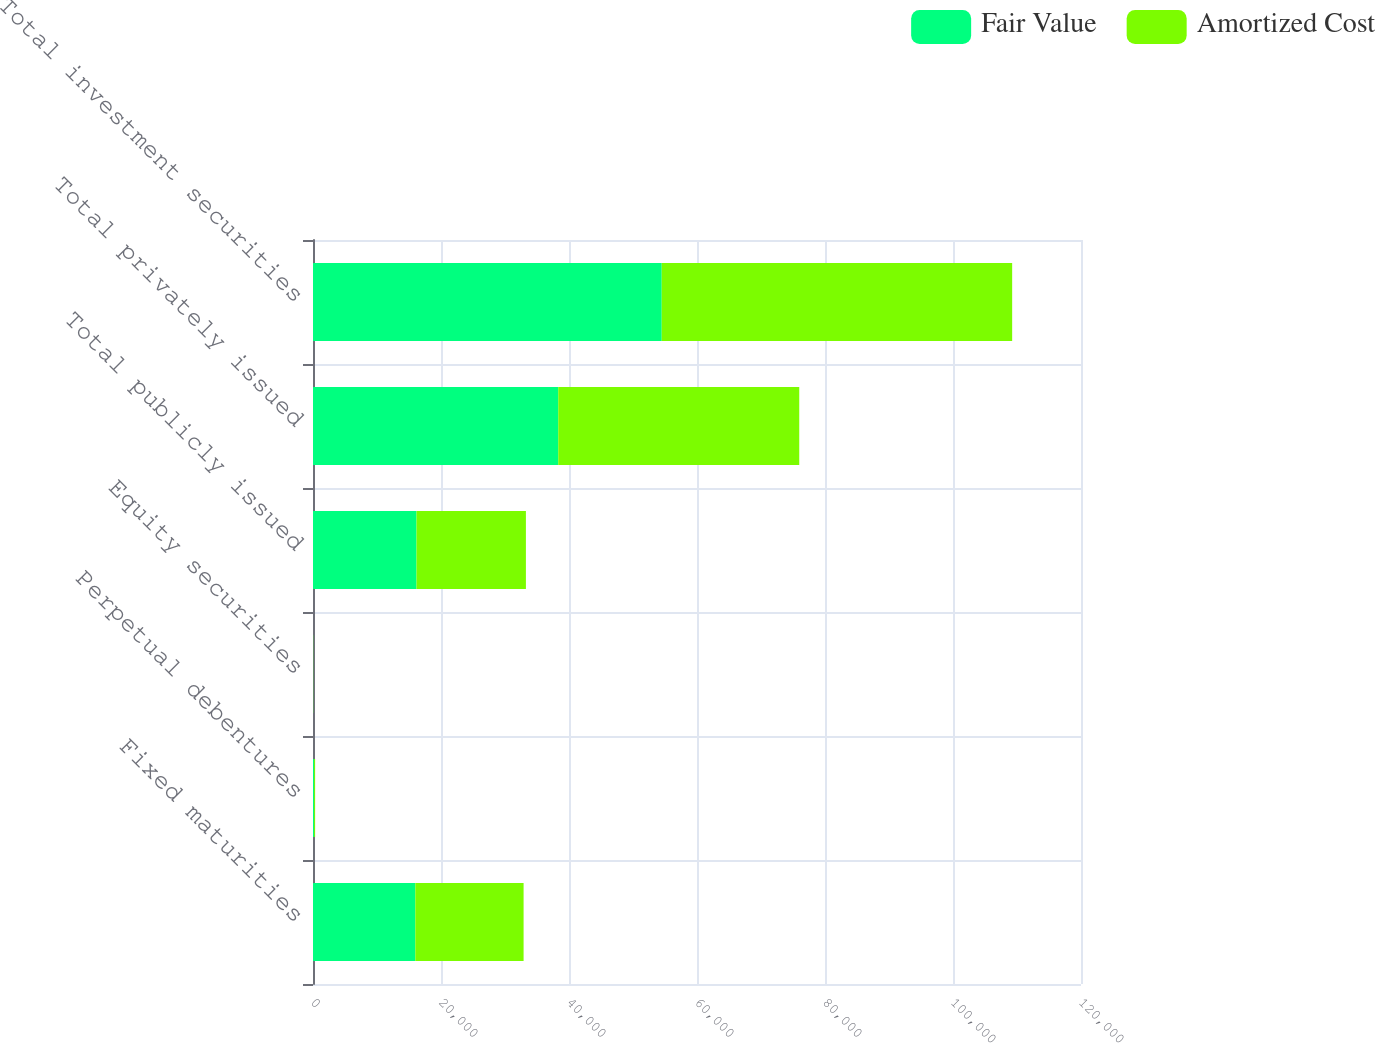Convert chart. <chart><loc_0><loc_0><loc_500><loc_500><stacked_bar_chart><ecel><fcel>Fixed maturities<fcel>Perpetual debentures<fcel>Equity securities<fcel>Total publicly issued<fcel>Total privately issued<fcel>Total investment securities<nl><fcel>Fair Value<fcel>15986<fcel>173<fcel>13<fcel>16172<fcel>38319<fcel>54491<nl><fcel>Amortized Cost<fcel>16919<fcel>157<fcel>19<fcel>17095<fcel>37658<fcel>54753<nl></chart> 